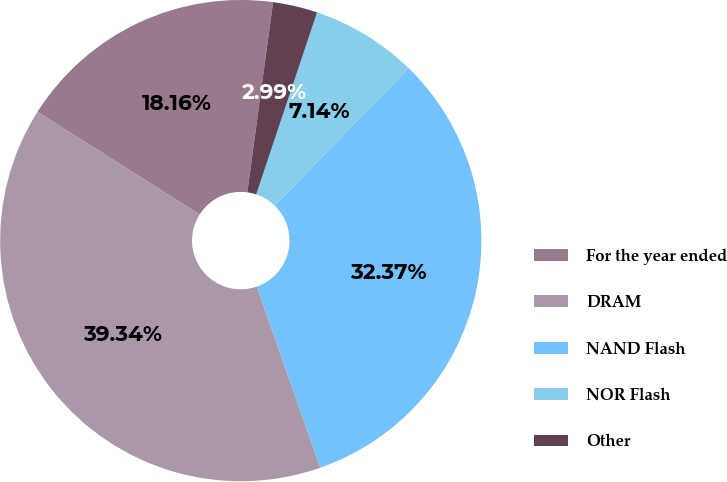Convert chart to OTSL. <chart><loc_0><loc_0><loc_500><loc_500><pie_chart><fcel>For the year ended<fcel>DRAM<fcel>NAND Flash<fcel>NOR Flash<fcel>Other<nl><fcel>18.16%<fcel>39.34%<fcel>32.37%<fcel>7.14%<fcel>2.99%<nl></chart> 